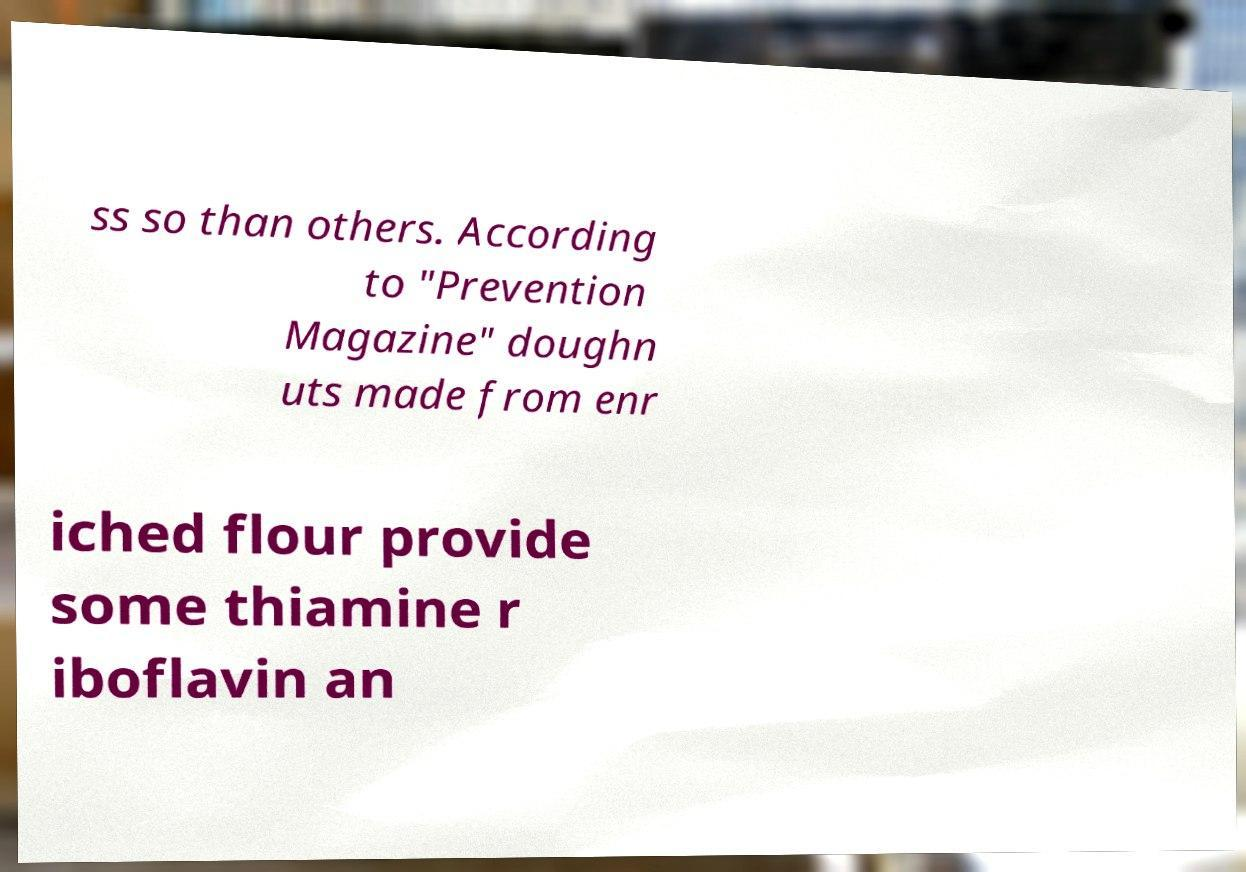What messages or text are displayed in this image? I need them in a readable, typed format. ss so than others. According to "Prevention Magazine" doughn uts made from enr iched flour provide some thiamine r iboflavin an 